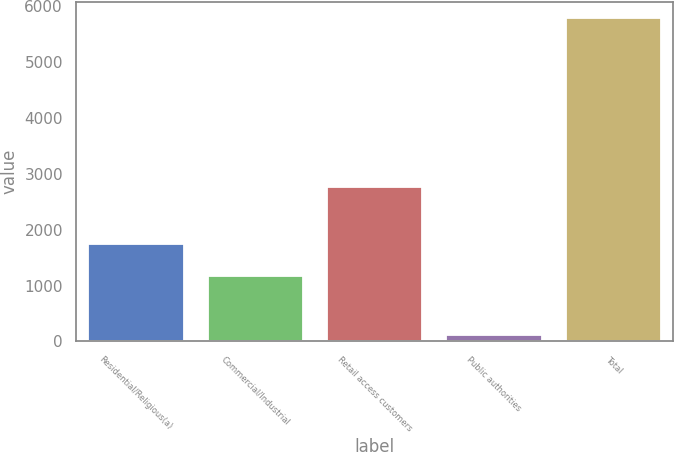Convert chart. <chart><loc_0><loc_0><loc_500><loc_500><bar_chart><fcel>Residential/Religious(a)<fcel>Commercial/Industrial<fcel>Retail access customers<fcel>Public authorities<fcel>Total<nl><fcel>1750<fcel>1168<fcel>2760<fcel>111<fcel>5789<nl></chart> 